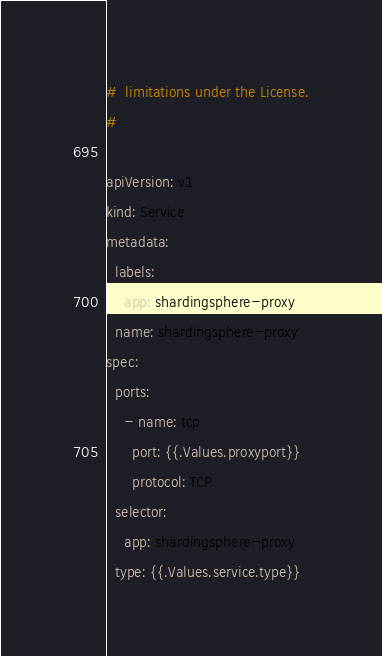Convert code to text. <code><loc_0><loc_0><loc_500><loc_500><_YAML_>#  limitations under the License.
#

apiVersion: v1
kind: Service
metadata:
  labels:
    app: shardingsphere-proxy
  name: shardingsphere-proxy
spec:
  ports:
    - name: tcp
      port: {{.Values.proxyport}}
      protocol: TCP
  selector:
    app: shardingsphere-proxy
  type: {{.Values.service.type}}
</code> 